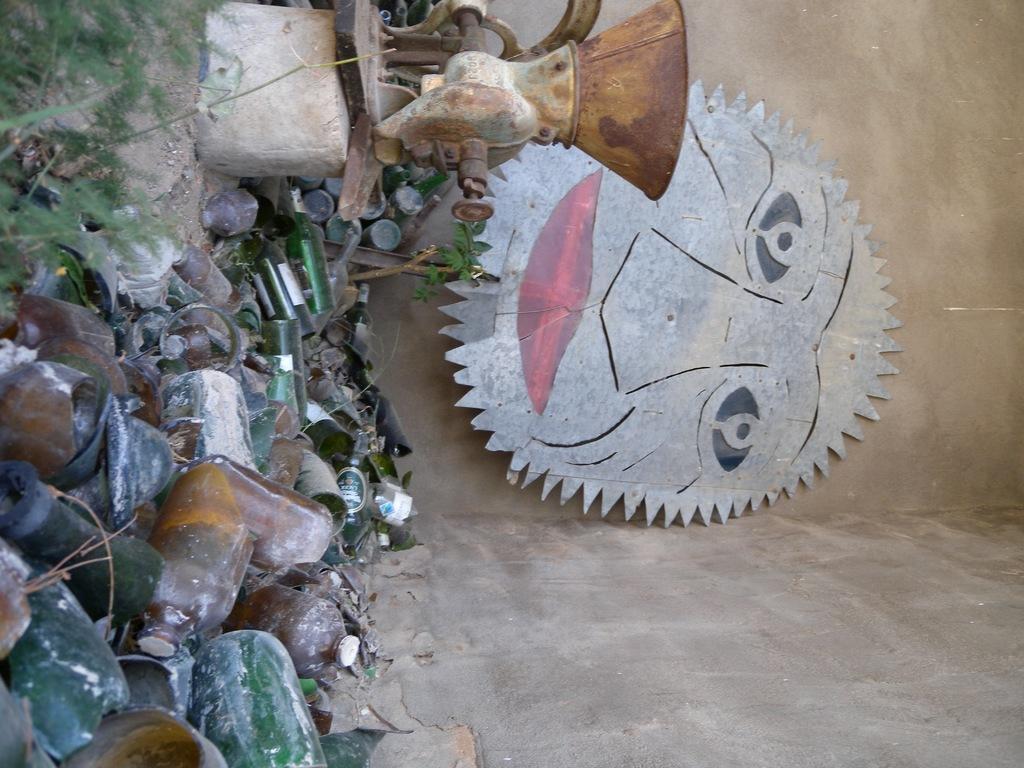Please provide a concise description of this image. This picture shows few bottles and we see a machine and grass on the ground and we see a wall. 